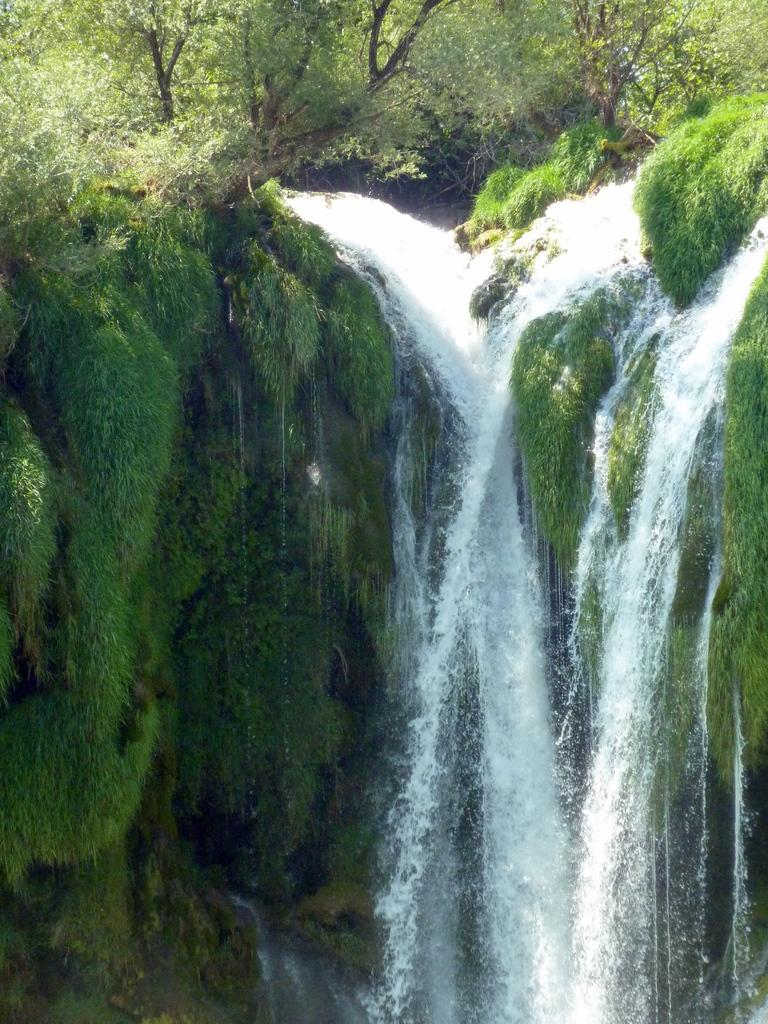What natural feature is the main subject of the picture? There is a waterfall in the picture. What can be seen at the top of the waterfall? Trees, plants, and grass are visible at the top of the waterfall. What type of stamp can be seen on the waterfall in the image? There is no stamp present on the waterfall in the image. What is the weight of the bee flying near the waterfall in the image? There is no bee present near the waterfall in the image. 